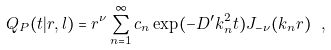Convert formula to latex. <formula><loc_0><loc_0><loc_500><loc_500>Q _ { P } ( t | r , l ) = r ^ { \nu } \sum _ { n = 1 } ^ { \infty } c _ { n } \exp ( - D ^ { \prime } k _ { n } ^ { 2 } t ) J _ { - \nu } ( k _ { n } r ) \ ,</formula> 